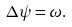<formula> <loc_0><loc_0><loc_500><loc_500>\Delta \psi = \omega .</formula> 